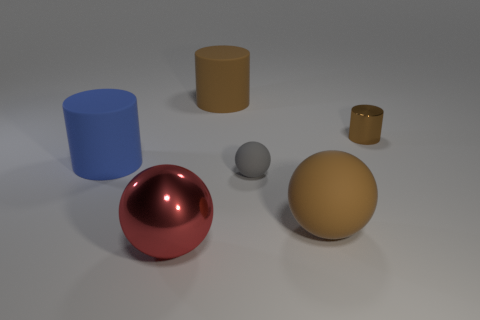What is the size of the shiny object that is in front of the tiny brown metal cylinder?
Offer a very short reply. Large. What number of other things are there of the same color as the shiny cylinder?
Your response must be concise. 2. What material is the big cylinder in front of the large cylinder behind the small brown metal cylinder?
Offer a terse response. Rubber. Does the metallic thing that is behind the blue rubber object have the same color as the big matte sphere?
Provide a succinct answer. Yes. What number of tiny brown shiny objects have the same shape as the small rubber thing?
Provide a succinct answer. 0. What is the size of the red thing that is made of the same material as the small cylinder?
Your answer should be compact. Large. There is a large brown rubber thing that is behind the tiny matte ball that is left of the brown matte ball; are there any balls to the left of it?
Give a very brief answer. Yes. There is a matte cylinder that is to the right of the red thing; is it the same size as the metallic cylinder?
Provide a succinct answer. No. What number of matte cylinders are the same size as the brown sphere?
Your response must be concise. 2. What is the size of the rubber cylinder that is the same color as the large matte sphere?
Your answer should be compact. Large. 